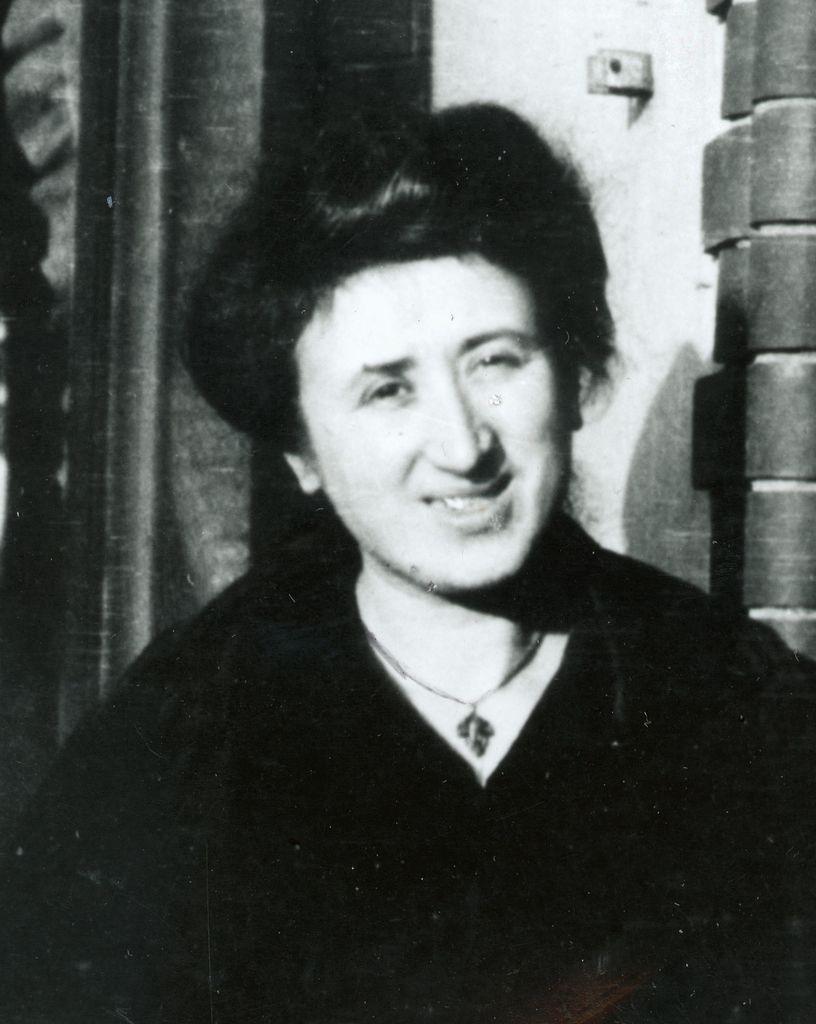Please provide a concise description of this image. This is a black and white picture. Here we can see a person. In the background we can see wall, pole, and other objects. 